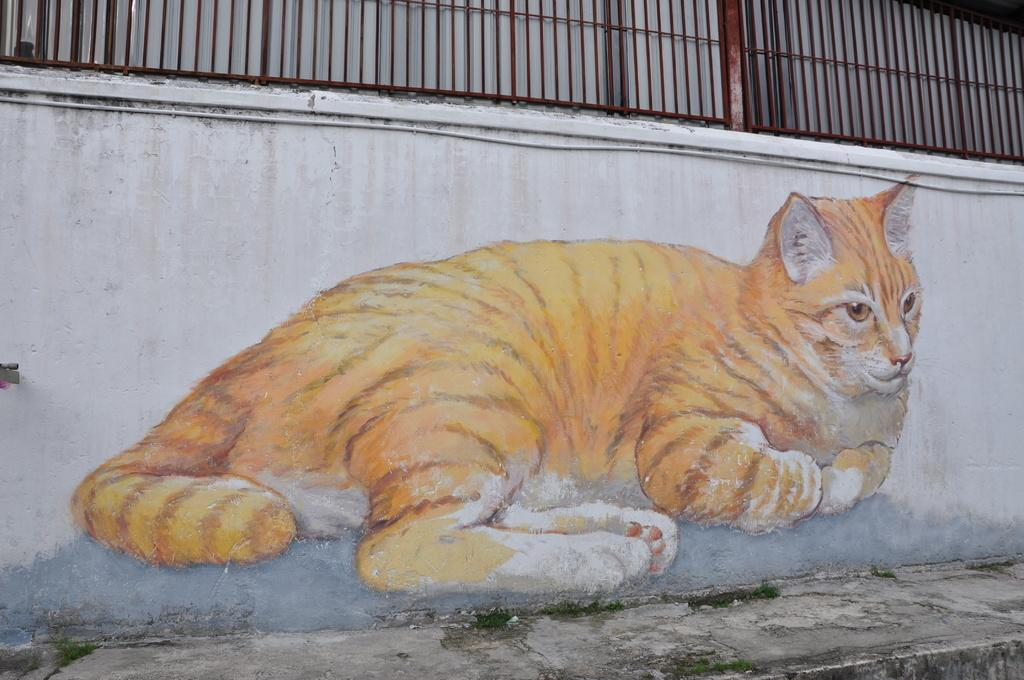What is located in the center of the image? There is a wall in the center of the image. What is on the wall? There is a painting on the wall. What can be seen at the top of the image? There is a railing at the top of the image. What is at the bottom of the image? There is a walkway at the bottom of the image. What type of cream is being used to paint the wall in the image? There is no cream being used to paint the wall in the image; it is a painting that is already on the wall. 